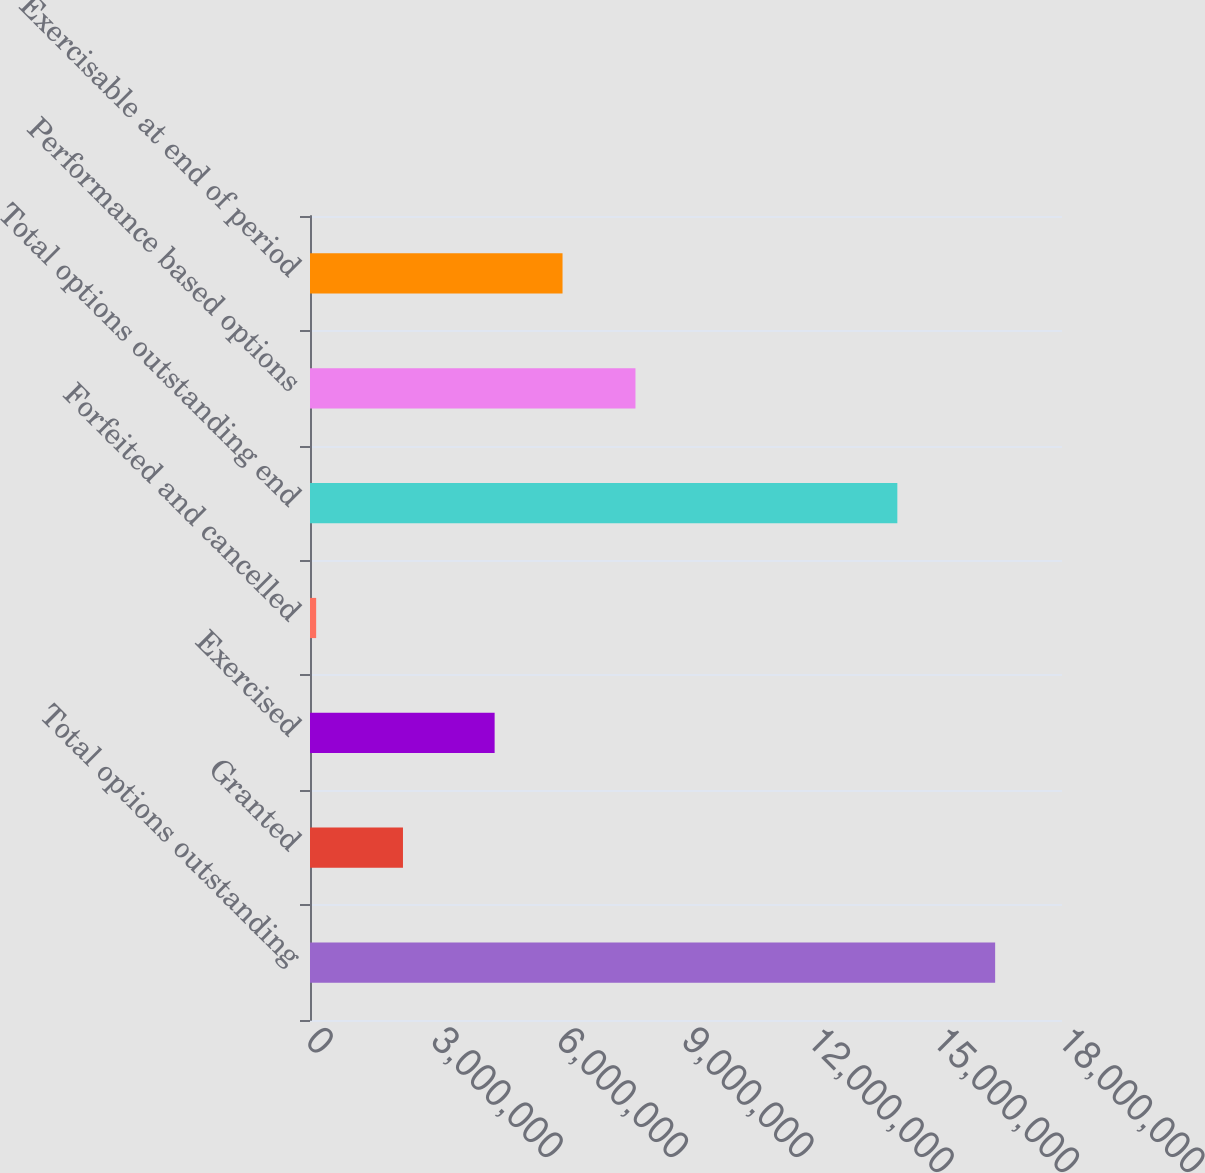<chart> <loc_0><loc_0><loc_500><loc_500><bar_chart><fcel>Total options outstanding<fcel>Granted<fcel>Exercised<fcel>Forfeited and cancelled<fcel>Total options outstanding end<fcel>Performance based options<fcel>Exercisable at end of period<nl><fcel>1.63999e+07<fcel>2.2255e+06<fcel>4.4194e+06<fcel>147400<fcel>1.40586e+07<fcel>7.7905e+06<fcel>6.04464e+06<nl></chart> 